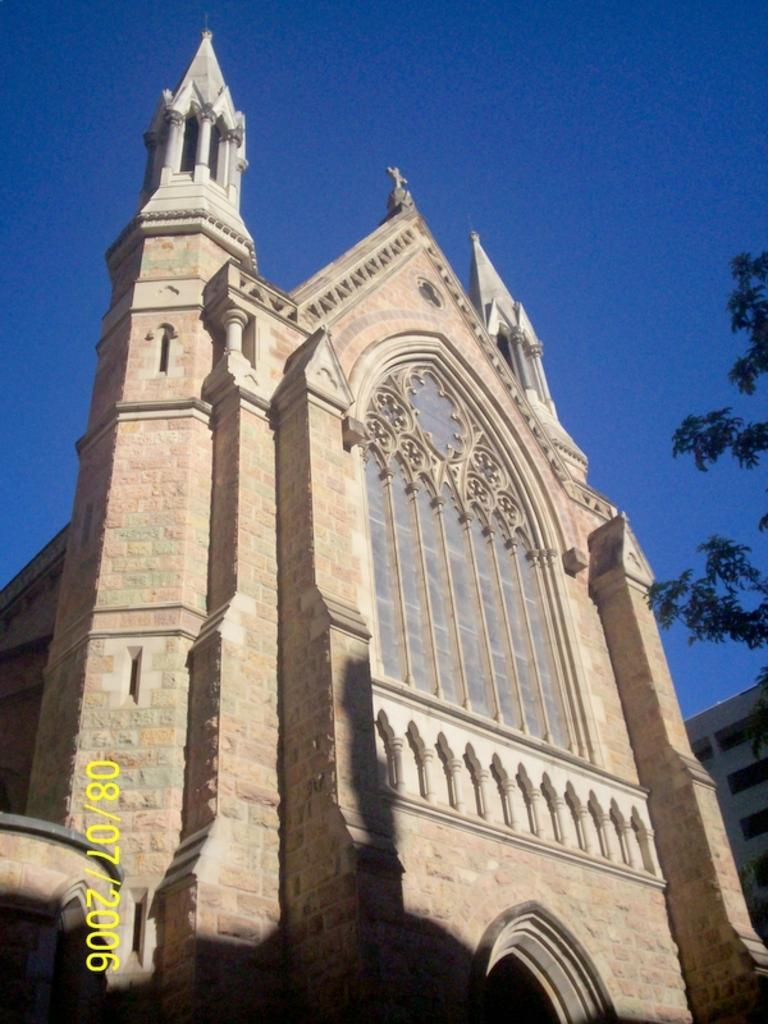What is the main subject in the center of the image? There is a building in the center of the image. What can be seen on the right side of the image? There is a tree on the right side of the image. What is visible in the background of the image? The sky is visible in the background of the image. How many oranges are hanging from the tree in the image? There are no oranges present in the image; it features a tree without any visible fruit. What type of vegetable is growing near the building in the image? There is no vegetable visible near the building in the image. 